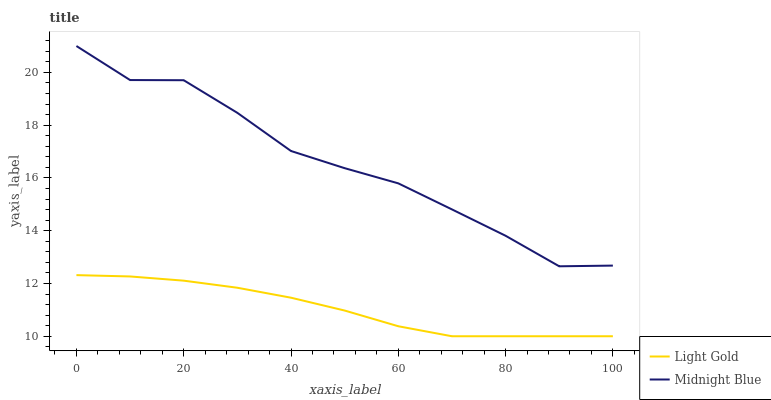Does Light Gold have the minimum area under the curve?
Answer yes or no. Yes. Does Midnight Blue have the maximum area under the curve?
Answer yes or no. Yes. Does Midnight Blue have the minimum area under the curve?
Answer yes or no. No. Is Light Gold the smoothest?
Answer yes or no. Yes. Is Midnight Blue the roughest?
Answer yes or no. Yes. Is Midnight Blue the smoothest?
Answer yes or no. No. Does Light Gold have the lowest value?
Answer yes or no. Yes. Does Midnight Blue have the lowest value?
Answer yes or no. No. Does Midnight Blue have the highest value?
Answer yes or no. Yes. Is Light Gold less than Midnight Blue?
Answer yes or no. Yes. Is Midnight Blue greater than Light Gold?
Answer yes or no. Yes. Does Light Gold intersect Midnight Blue?
Answer yes or no. No. 